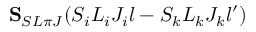<formula> <loc_0><loc_0><loc_500><loc_500>{ S } _ { S L \pi J } ( S _ { i } L _ { i } J _ { i } l - S _ { k } L _ { k } J _ { k } l ^ { \prime } )</formula> 